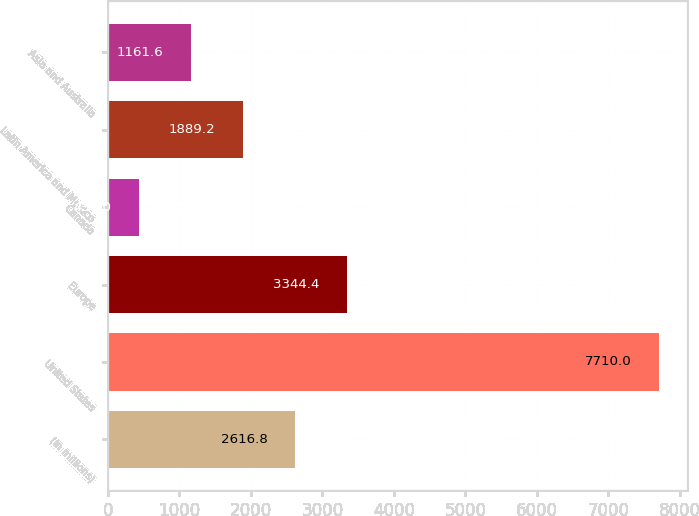Convert chart. <chart><loc_0><loc_0><loc_500><loc_500><bar_chart><fcel>(In millions)<fcel>United States<fcel>Europe<fcel>Canada<fcel>Latin America and Mexico<fcel>Asia and Australia<nl><fcel>2616.8<fcel>7710<fcel>3344.4<fcel>434<fcel>1889.2<fcel>1161.6<nl></chart> 